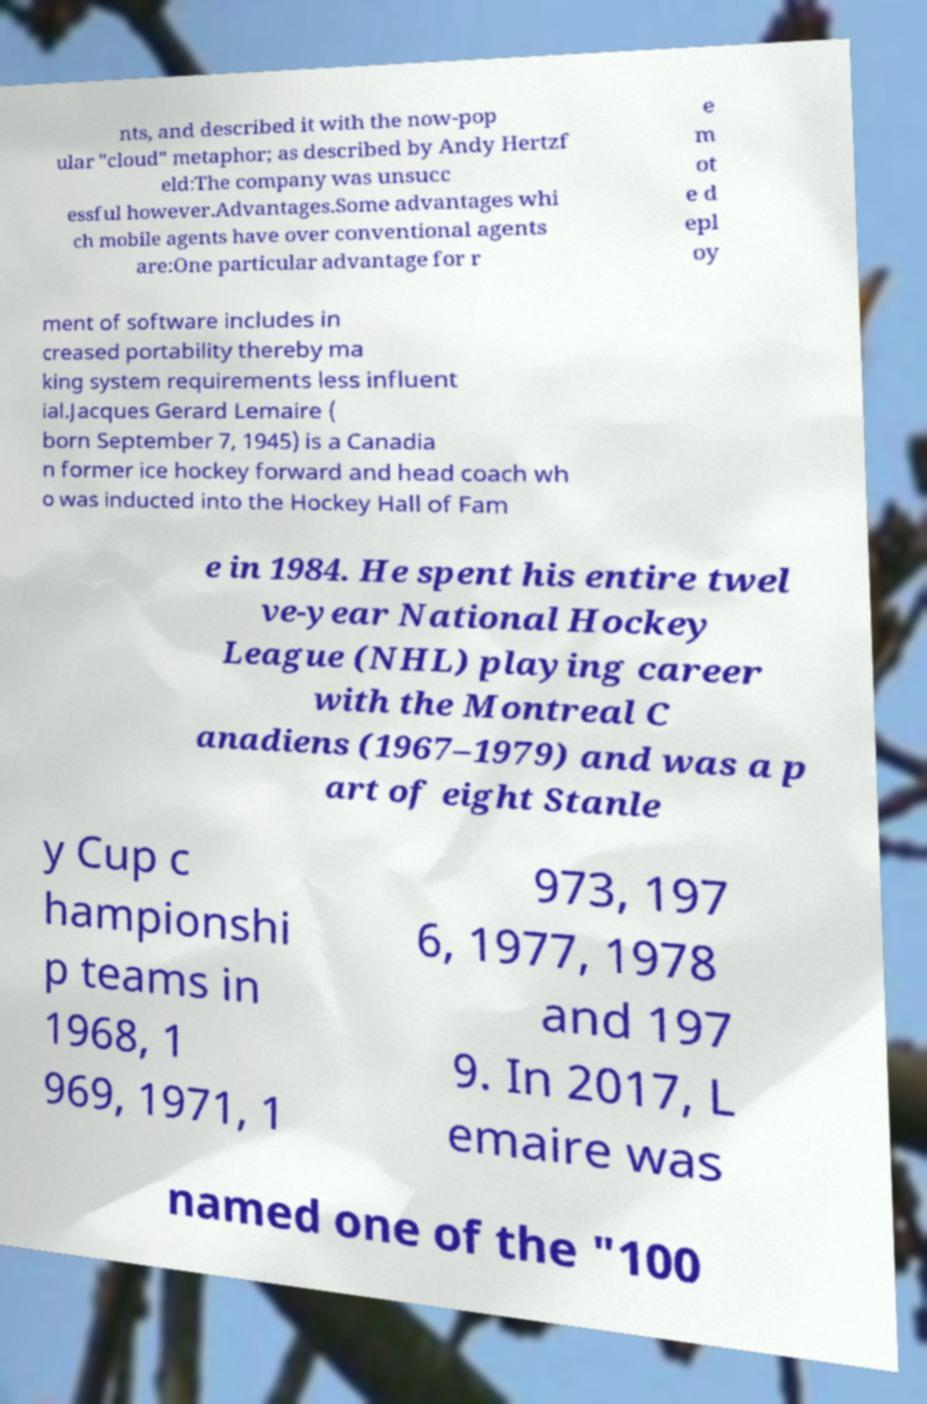Please read and relay the text visible in this image. What does it say? nts, and described it with the now-pop ular "cloud" metaphor; as described by Andy Hertzf eld:The company was unsucc essful however.Advantages.Some advantages whi ch mobile agents have over conventional agents are:One particular advantage for r e m ot e d epl oy ment of software includes in creased portability thereby ma king system requirements less influent ial.Jacques Gerard Lemaire ( born September 7, 1945) is a Canadia n former ice hockey forward and head coach wh o was inducted into the Hockey Hall of Fam e in 1984. He spent his entire twel ve-year National Hockey League (NHL) playing career with the Montreal C anadiens (1967–1979) and was a p art of eight Stanle y Cup c hampionshi p teams in 1968, 1 969, 1971, 1 973, 197 6, 1977, 1978 and 197 9. In 2017, L emaire was named one of the "100 